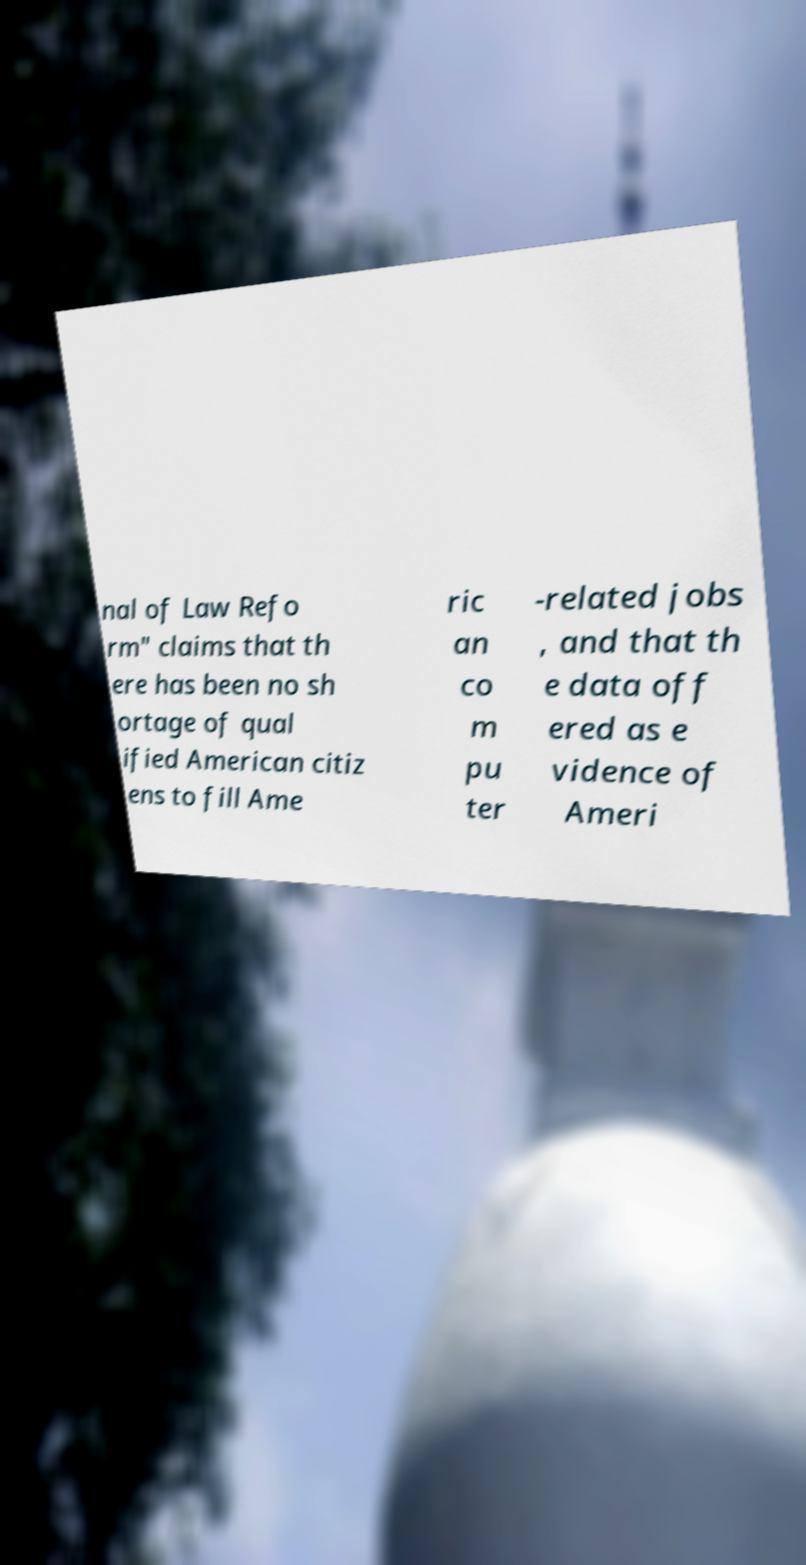There's text embedded in this image that I need extracted. Can you transcribe it verbatim? nal of Law Refo rm" claims that th ere has been no sh ortage of qual ified American citiz ens to fill Ame ric an co m pu ter -related jobs , and that th e data off ered as e vidence of Ameri 